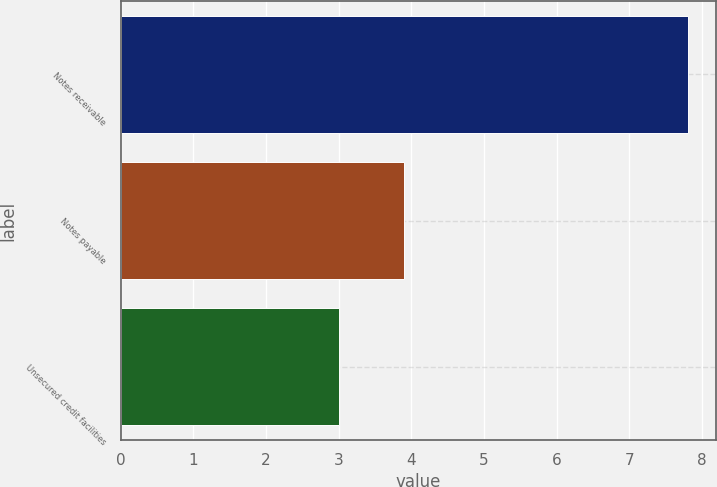Convert chart to OTSL. <chart><loc_0><loc_0><loc_500><loc_500><bar_chart><fcel>Notes receivable<fcel>Notes payable<fcel>Unsecured credit facilities<nl><fcel>7.8<fcel>3.9<fcel>3<nl></chart> 